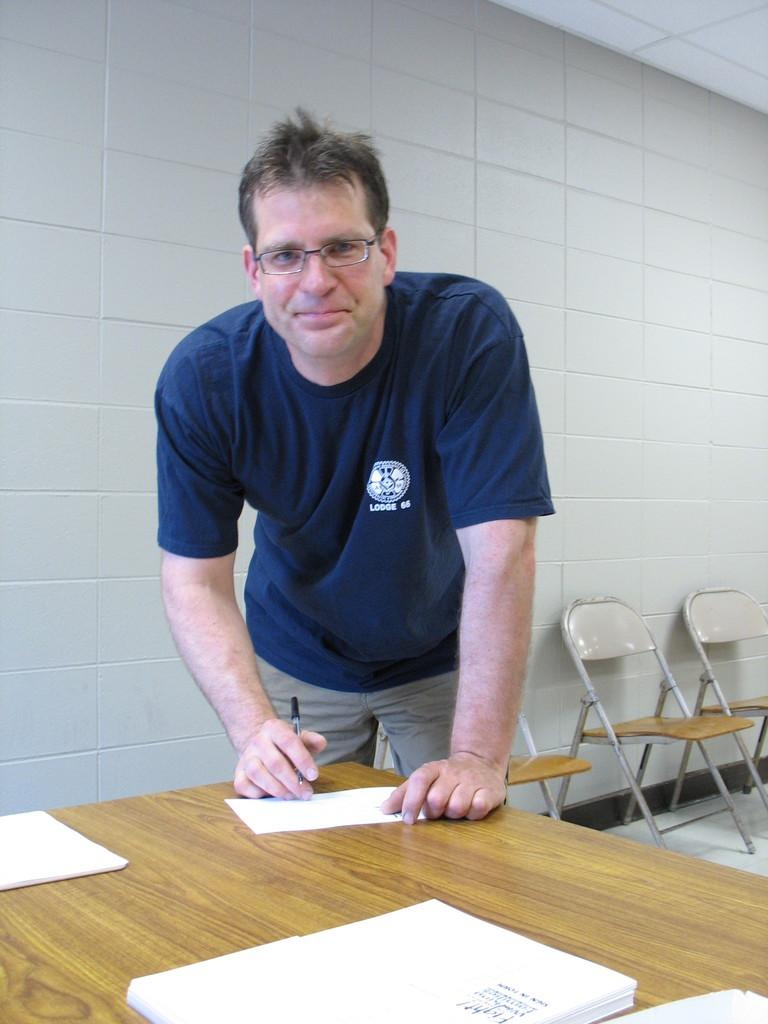<image>
Share a concise interpretation of the image provided. A man at a table is wearing a shirt that says Lodge 66 